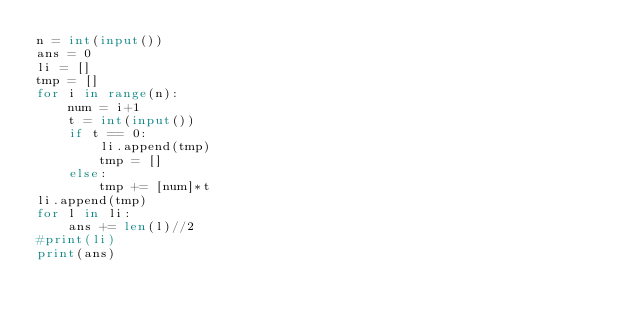<code> <loc_0><loc_0><loc_500><loc_500><_Python_>n = int(input())
ans = 0
li = []
tmp = []
for i in range(n):
    num = i+1
    t = int(input())
    if t == 0:
        li.append(tmp)
        tmp = []
    else:
        tmp += [num]*t
li.append(tmp)
for l in li:
    ans += len(l)//2
#print(li)
print(ans)</code> 